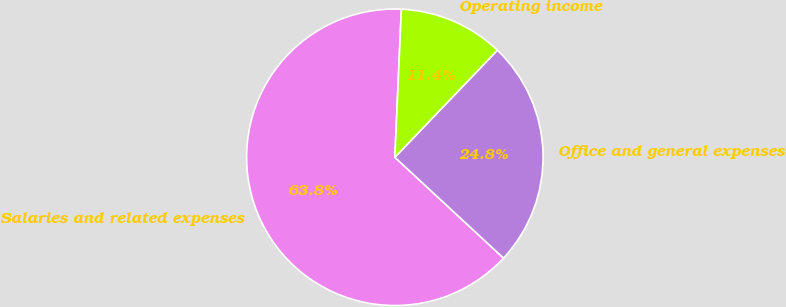Convert chart. <chart><loc_0><loc_0><loc_500><loc_500><pie_chart><fcel>Salaries and related expenses<fcel>Office and general expenses<fcel>Operating income<nl><fcel>63.8%<fcel>24.75%<fcel>11.45%<nl></chart> 